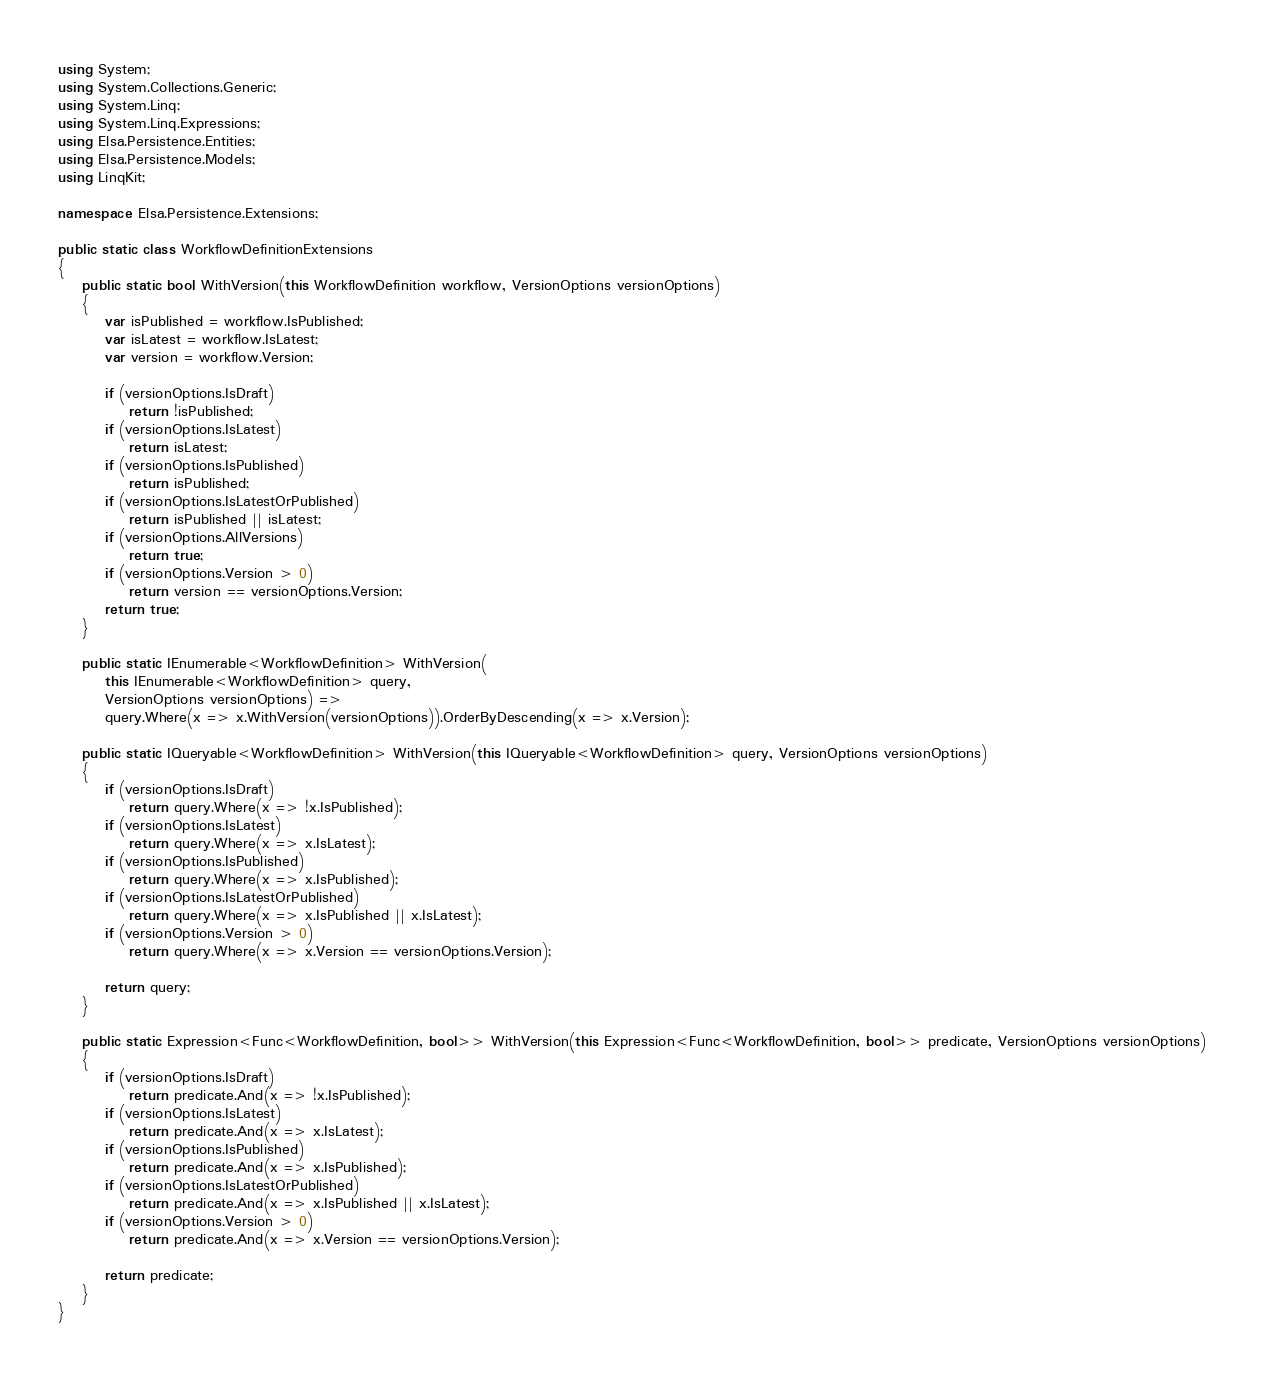<code> <loc_0><loc_0><loc_500><loc_500><_C#_>using System;
using System.Collections.Generic;
using System.Linq;
using System.Linq.Expressions;
using Elsa.Persistence.Entities;
using Elsa.Persistence.Models;
using LinqKit;

namespace Elsa.Persistence.Extensions;

public static class WorkflowDefinitionExtensions
{
    public static bool WithVersion(this WorkflowDefinition workflow, VersionOptions versionOptions)
    {
        var isPublished = workflow.IsPublished;
        var isLatest = workflow.IsLatest;
        var version = workflow.Version;

        if (versionOptions.IsDraft)
            return !isPublished;
        if (versionOptions.IsLatest)
            return isLatest;
        if (versionOptions.IsPublished)
            return isPublished;
        if (versionOptions.IsLatestOrPublished)
            return isPublished || isLatest;
        if (versionOptions.AllVersions)
            return true;
        if (versionOptions.Version > 0)
            return version == versionOptions.Version;
        return true;
    }

    public static IEnumerable<WorkflowDefinition> WithVersion(
        this IEnumerable<WorkflowDefinition> query,
        VersionOptions versionOptions) =>
        query.Where(x => x.WithVersion(versionOptions)).OrderByDescending(x => x.Version);

    public static IQueryable<WorkflowDefinition> WithVersion(this IQueryable<WorkflowDefinition> query, VersionOptions versionOptions)
    {
        if (versionOptions.IsDraft)
            return query.Where(x => !x.IsPublished);
        if (versionOptions.IsLatest)
            return query.Where(x => x.IsLatest);
        if (versionOptions.IsPublished)
            return query.Where(x => x.IsPublished);
        if (versionOptions.IsLatestOrPublished)
            return query.Where(x => x.IsPublished || x.IsLatest);
        if (versionOptions.Version > 0)
            return query.Where(x => x.Version == versionOptions.Version);

        return query;
    }

    public static Expression<Func<WorkflowDefinition, bool>> WithVersion(this Expression<Func<WorkflowDefinition, bool>> predicate, VersionOptions versionOptions)
    {
        if (versionOptions.IsDraft)
            return predicate.And(x => !x.IsPublished);
        if (versionOptions.IsLatest)
            return predicate.And(x => x.IsLatest);
        if (versionOptions.IsPublished)
            return predicate.And(x => x.IsPublished);
        if (versionOptions.IsLatestOrPublished)
            return predicate.And(x => x.IsPublished || x.IsLatest);
        if (versionOptions.Version > 0)
            return predicate.And(x => x.Version == versionOptions.Version);

        return predicate;
    }
}</code> 